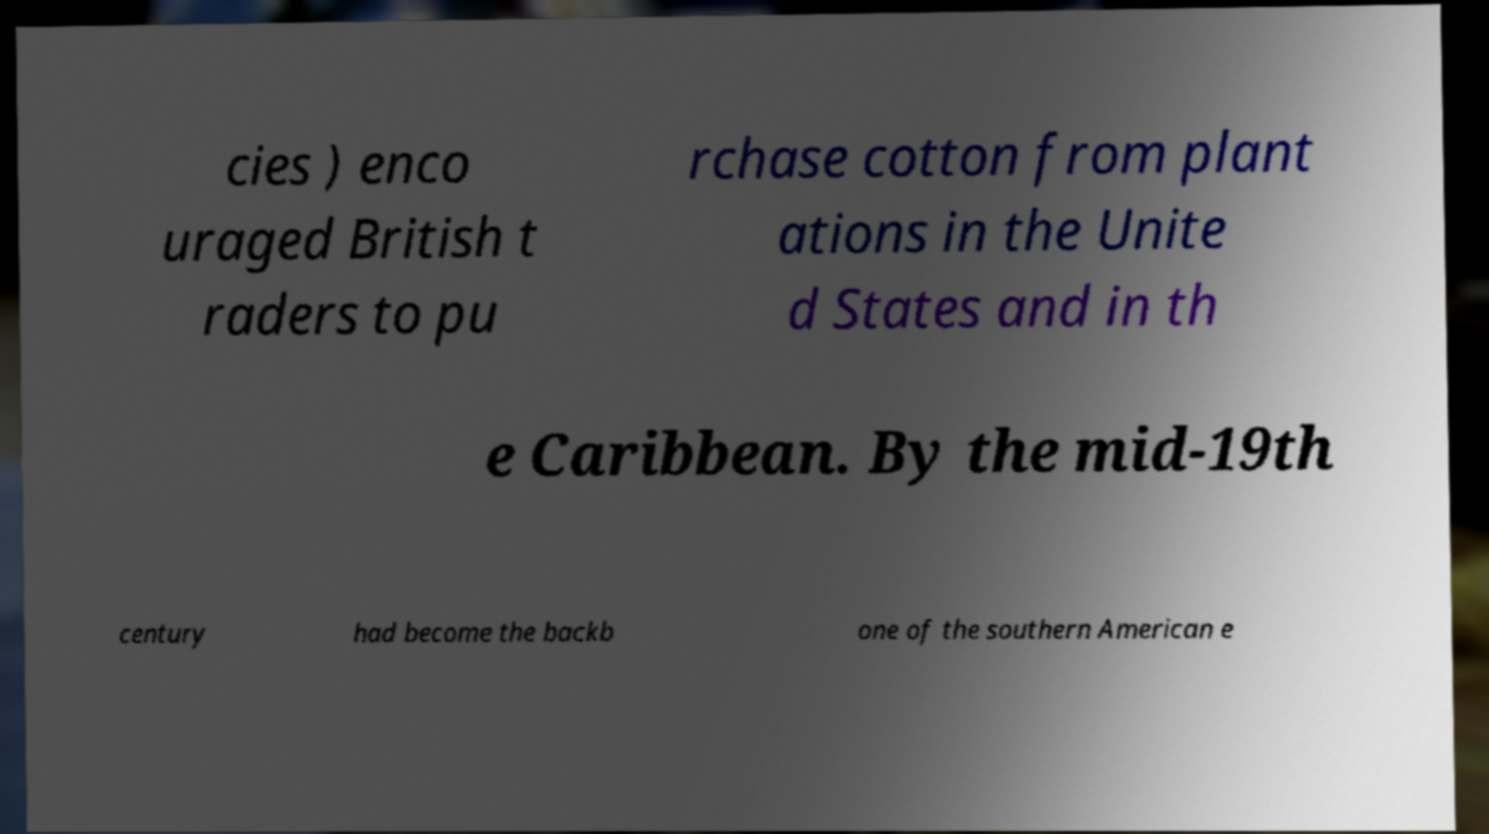Could you assist in decoding the text presented in this image and type it out clearly? cies ) enco uraged British t raders to pu rchase cotton from plant ations in the Unite d States and in th e Caribbean. By the mid-19th century had become the backb one of the southern American e 